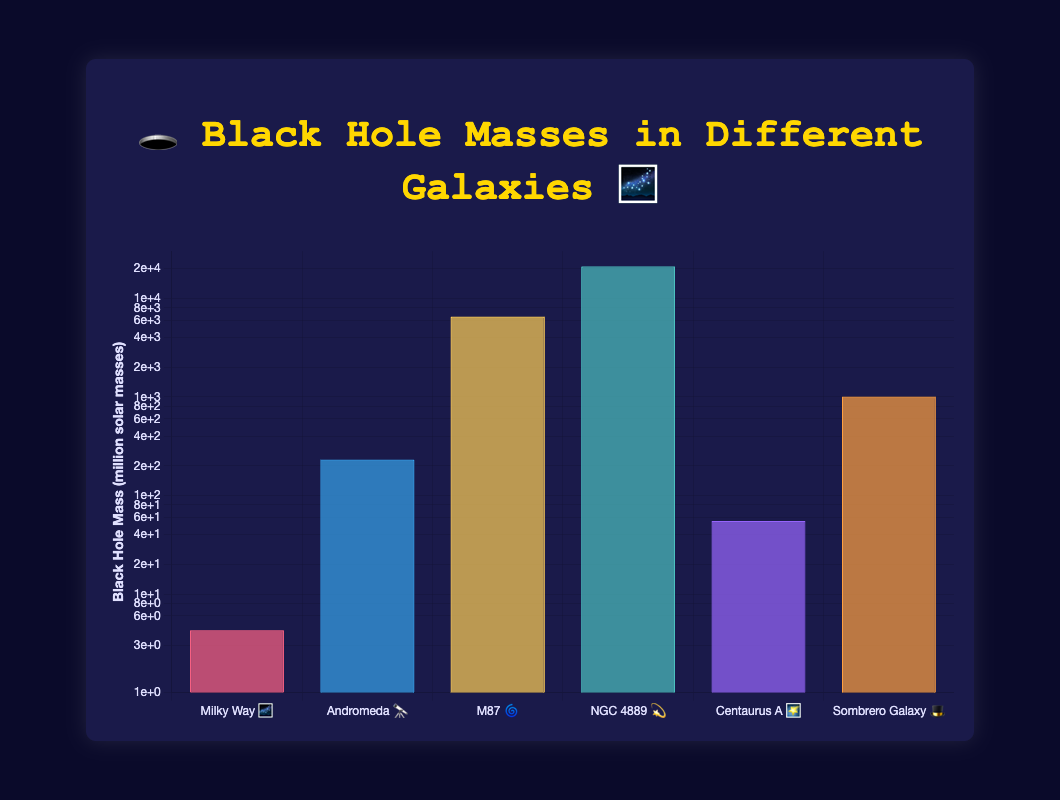What's the range of black hole masses observed? The range is calculated by subtracting the smallest black hole mass (4.3 million solar masses) from the largest black hole mass (21000 million solar masses). 21000 - 4.3 = 20995.7.
Answer: 20995.7 million solar masses Which galaxy has the black hole with the smallest mass? The smallest mass on the chart is 4.3 million solar masses, and it is associated with "Milky Way 🌌".
Answer: Milky Way 🌌 Which galaxy shows the largest black hole mass? The largest mass on the chart is 21000 million solar masses, associated with "NGC 4889 💫".
Answer: NGC 4889 💫 How many galaxies have black hole masses greater than 1000 million solar masses? Galaxies meeting this criteria are Andromeda 🔭, M87 🌀, NGC 4889 💫, and Sombrero Galaxy 🎩. Counting these, we get 4 galaxies.
Answer: 4 What is the combined mass of black holes in Milky Way 🌌 and Centaurus A 🌠? Adding the masses of black holes in these galaxies: 4.3 million (Milky Way 🌌) + 55 million (Centaurus A 🌠) = 59.3 million solar masses.
Answer: 59.3 million solar masses What's the approximate doubling factor from Milky Way’s black hole mass to Andromeda’s? Divide Andromeda's mass by Milky Way’s mass: 230 / 4.3 ≈ 53.49.
Answer: About 53.49 Does any galaxy have a black hole mass within a factor of 2 of Milky Way's black hole mass? Doubling Milky Way’s 4.3 million solar masses gives 8.6 million. Checking the chart, no galaxy's black hole mass is within this range.
Answer: No What is the median black hole mass among the listed galaxies? Ordering the black hole masses: 4.3, 55, 230, 1000, 6500, 21000. The median for an even number of entries is the average of the two middle values: (230 + 1000) / 2 = 615 million solar masses.
Answer: 615 million solar masses 